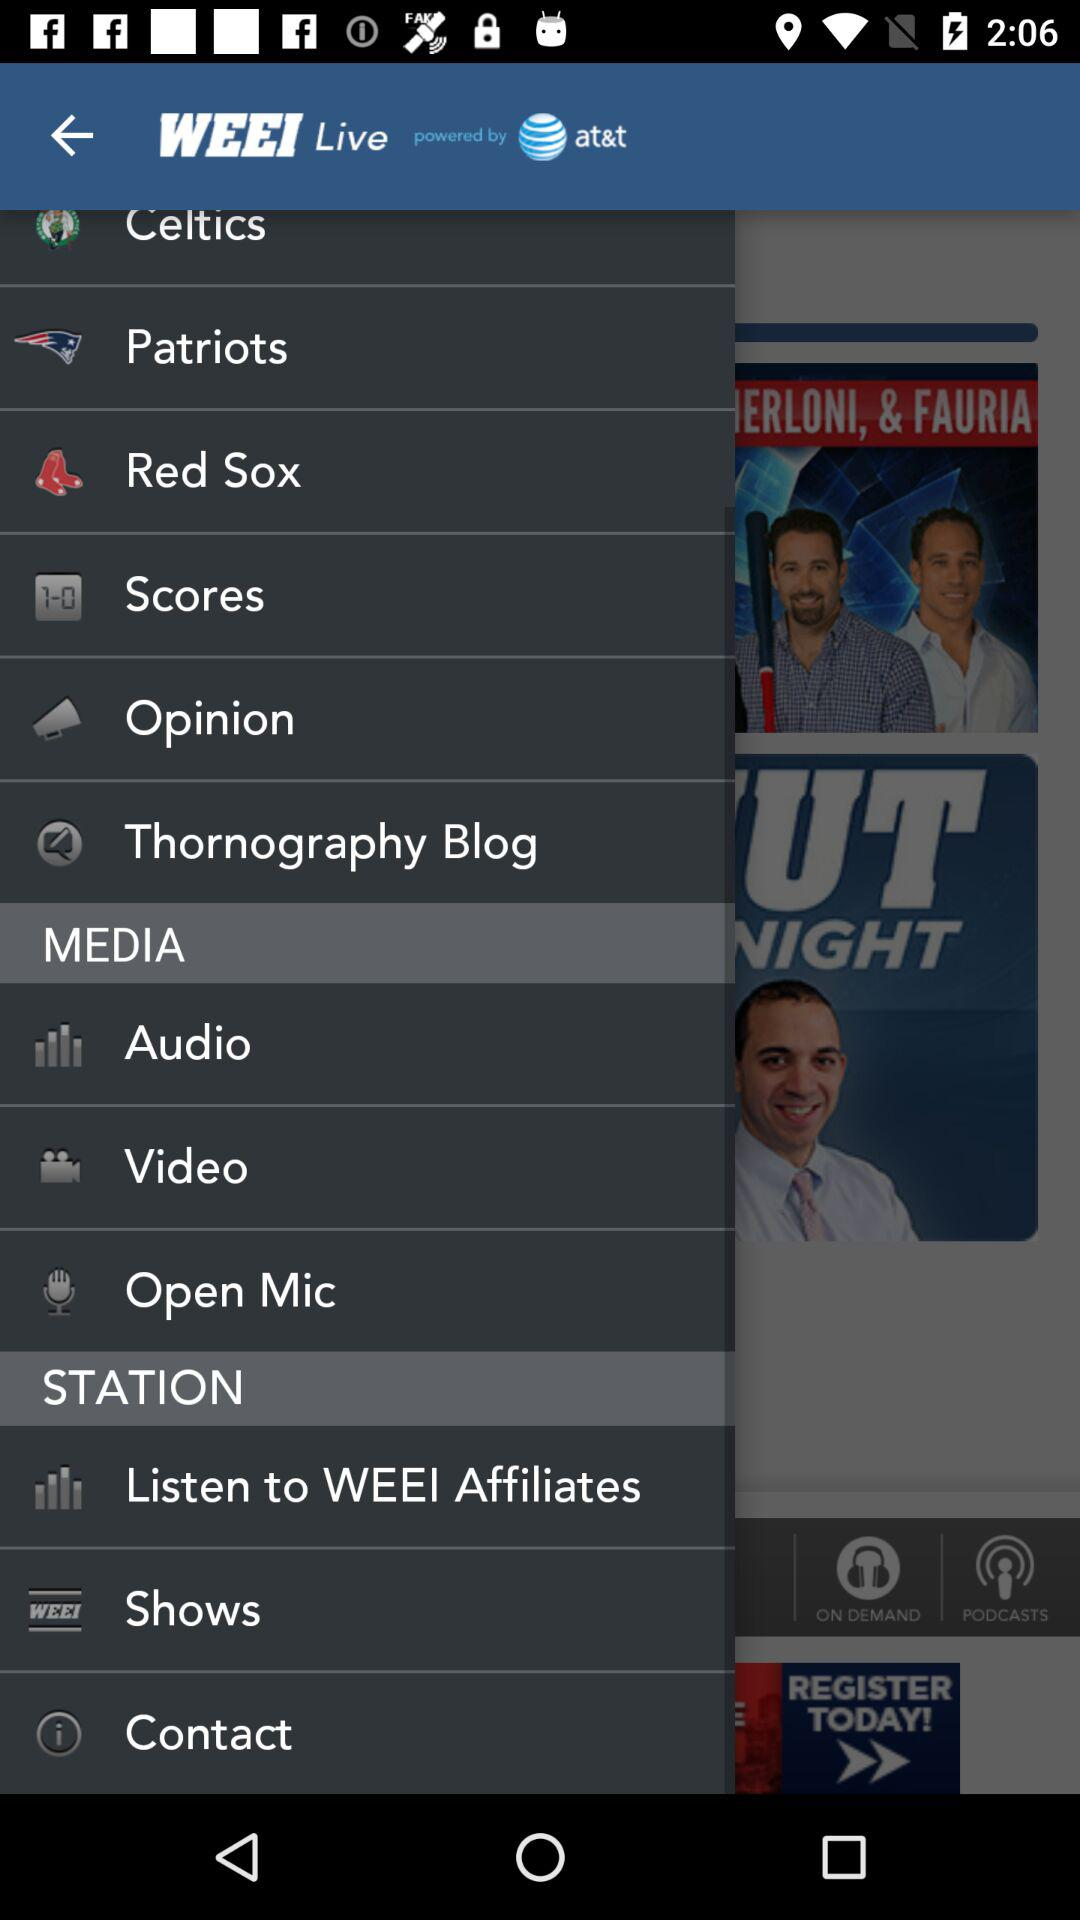What is the name of the application? The name of the application is "WEEI". 